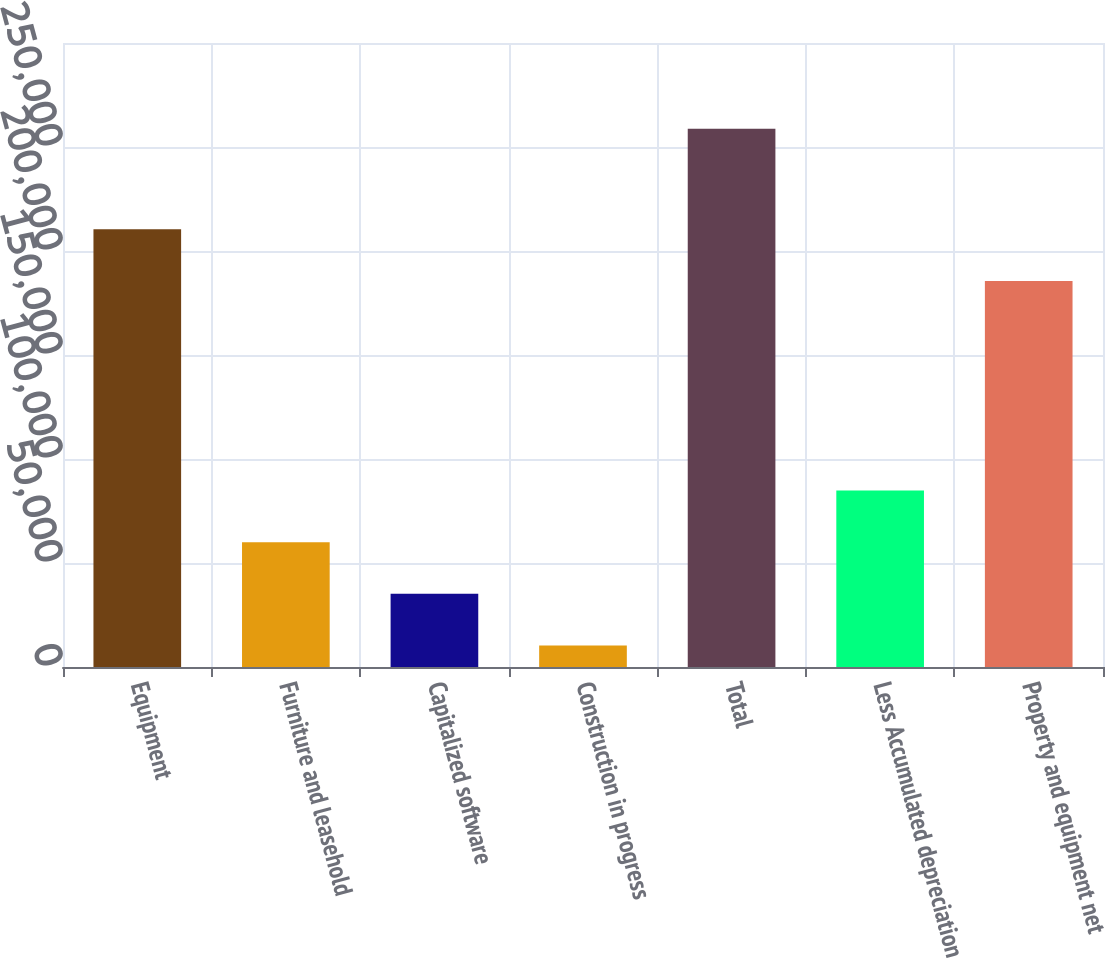<chart> <loc_0><loc_0><loc_500><loc_500><bar_chart><fcel>Equipment<fcel>Furniture and leasehold<fcel>Capitalized software<fcel>Construction in progress<fcel>Total<fcel>Less Accumulated depreciation<fcel>Property and equipment net<nl><fcel>210423<fcel>60020.6<fcel>35171.8<fcel>10323<fcel>258811<fcel>84869.4<fcel>185574<nl></chart> 